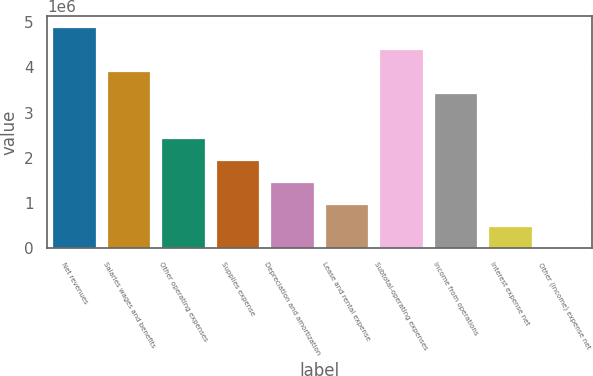<chart> <loc_0><loc_0><loc_500><loc_500><bar_chart><fcel>Net revenues<fcel>Salaries wages and benefits<fcel>Other operating expenses<fcel>Supplies expense<fcel>Depreciation and amortization<fcel>Lease and rental expense<fcel>Subtotal-operating expenses<fcel>Income from operations<fcel>Interest expense net<fcel>Other (income) expense net<nl><fcel>4.89118e+06<fcel>3.91294e+06<fcel>2.44559e+06<fcel>1.95647e+06<fcel>1.46735e+06<fcel>978236<fcel>4.40206e+06<fcel>3.42382e+06<fcel>489119<fcel>0.79<nl></chart> 